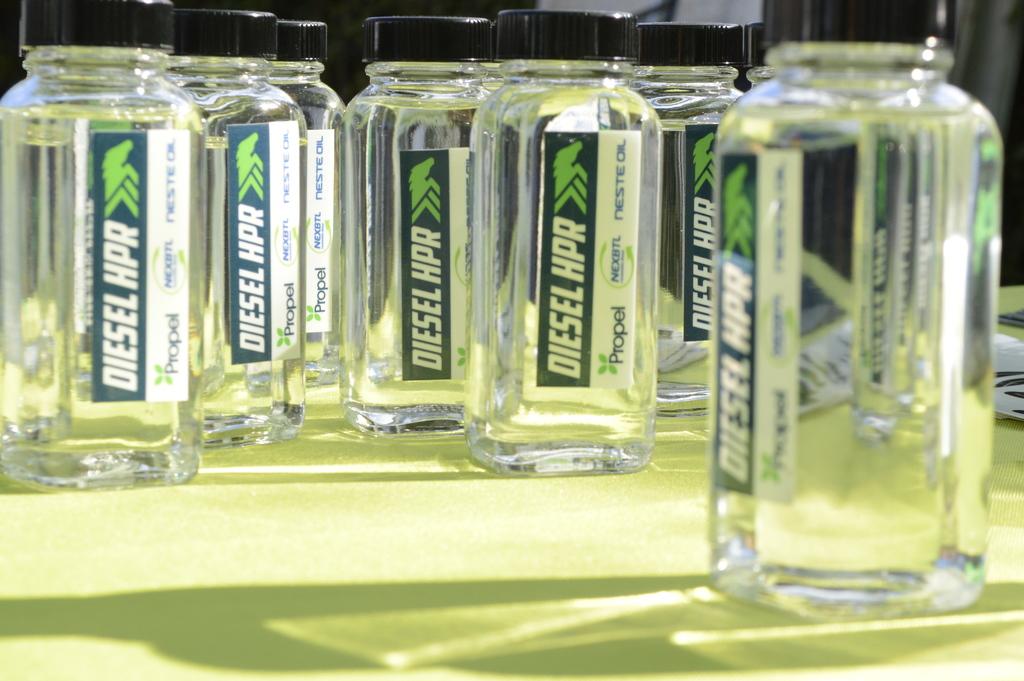What do these bottles say?
Provide a succinct answer. Diesel hpr. What company is shown under bottle name?
Provide a succinct answer. Propel. 